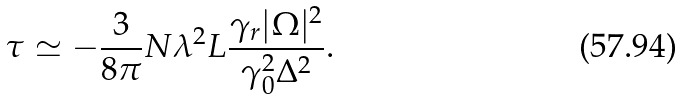Convert formula to latex. <formula><loc_0><loc_0><loc_500><loc_500>\tau \simeq - \frac { 3 } { 8 \pi } N \lambda ^ { 2 } L \frac { \gamma _ { r } | \Omega | ^ { 2 } } { \gamma _ { 0 } ^ { 2 } \Delta ^ { 2 } } .</formula> 